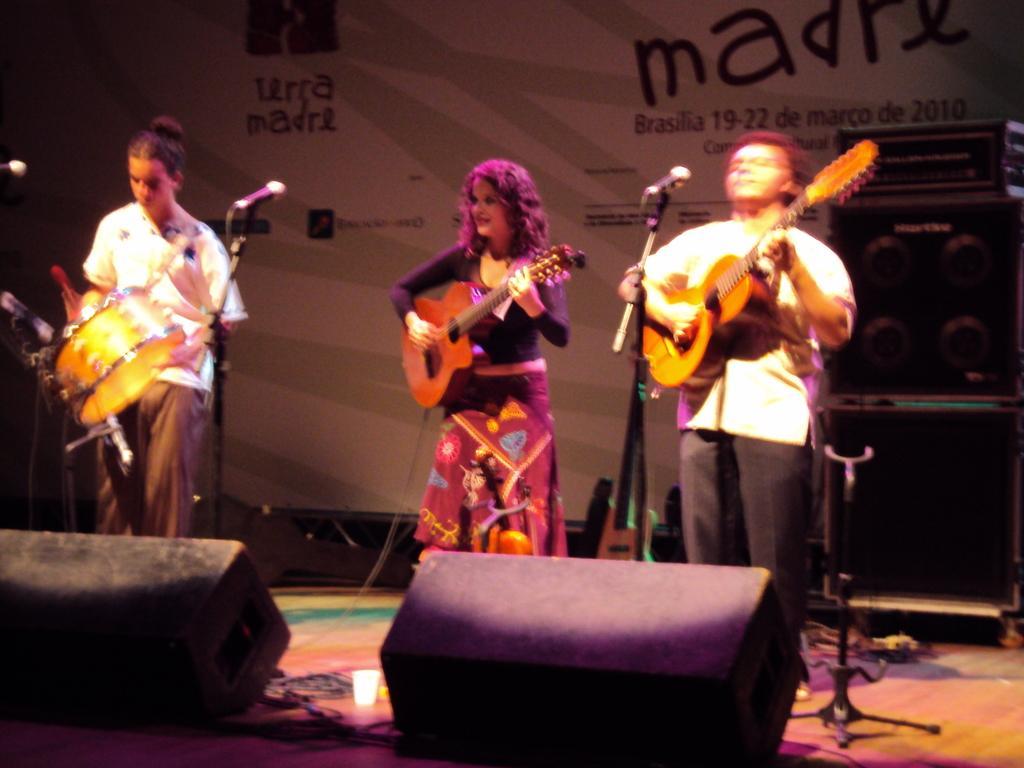Please provide a concise description of this image. This 3 persons are standing and playing a musical instruments in-front of mic. These are focusing lights. This is an electronic device. 